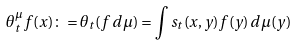Convert formula to latex. <formula><loc_0><loc_0><loc_500><loc_500>\theta _ { t } ^ { \mu } f ( x ) \colon = \theta _ { t } ( f \, d \mu ) = \int s _ { t } ( x , y ) f ( y ) \, d \mu ( y )</formula> 